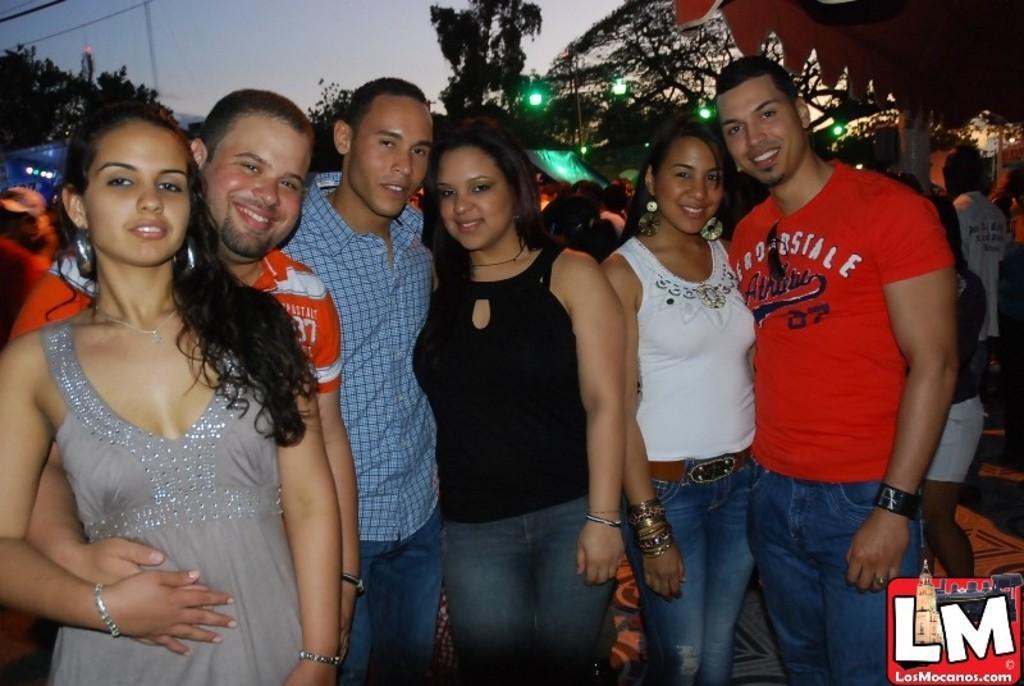Describe this image in one or two sentences. In this image I can see a group of people standing. In the background, I can see the trees, lights and the sky. 